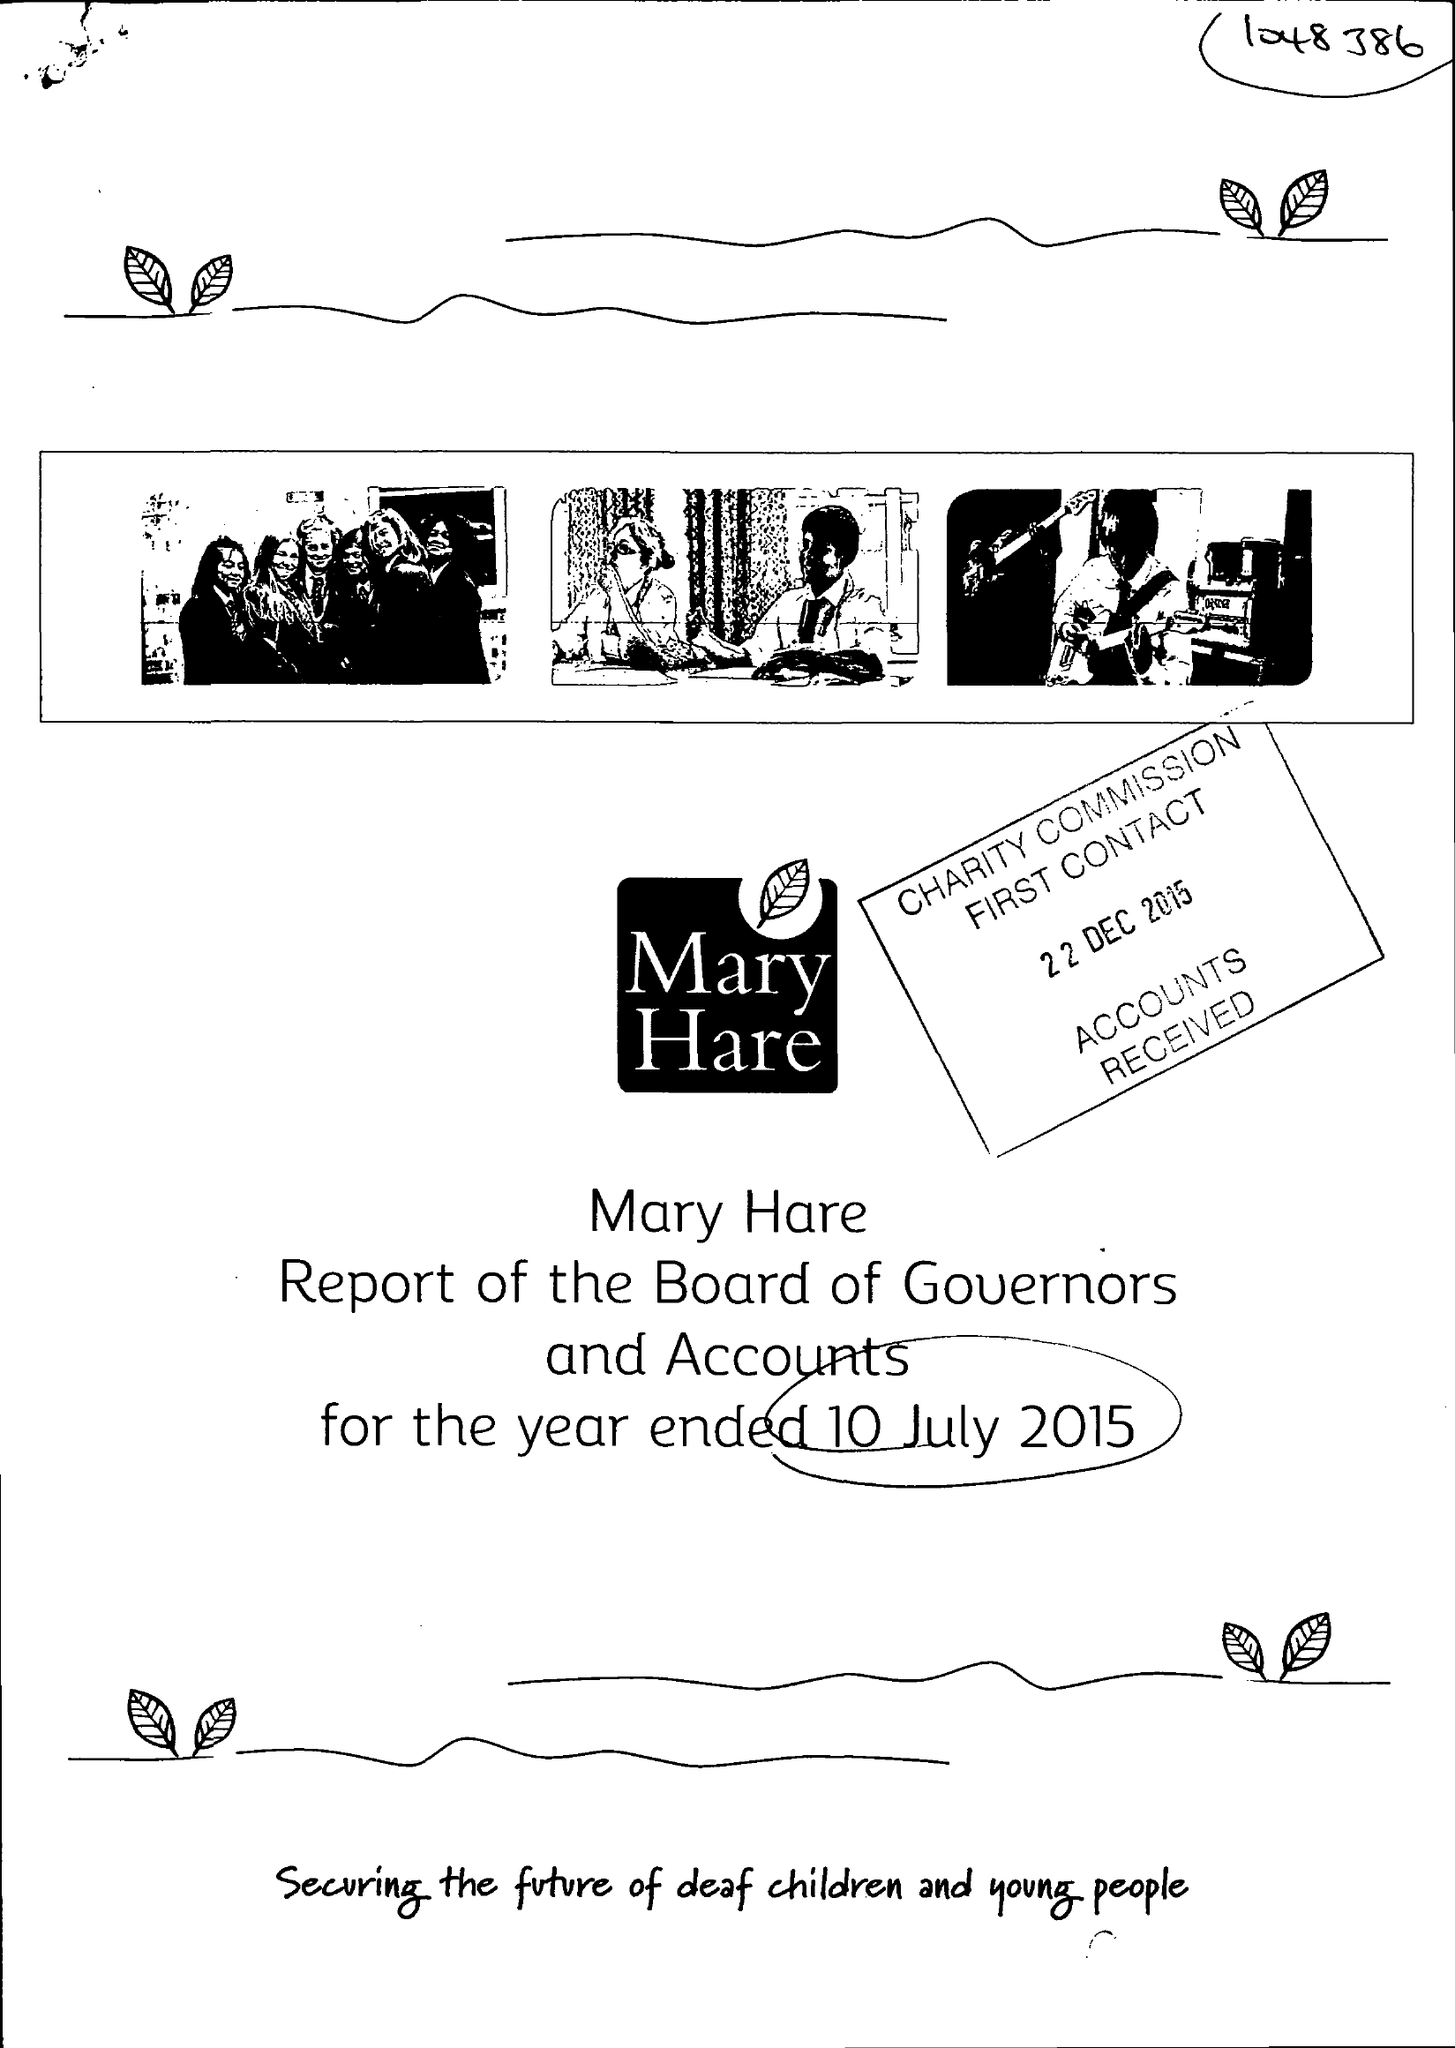What is the value for the income_annually_in_british_pounds?
Answer the question using a single word or phrase. 10185000.00 